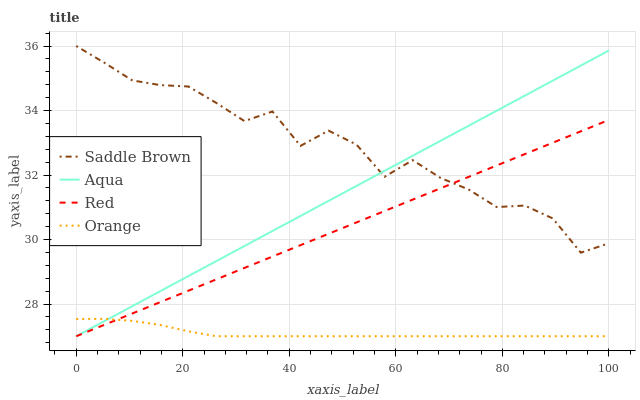Does Orange have the minimum area under the curve?
Answer yes or no. Yes. Does Saddle Brown have the maximum area under the curve?
Answer yes or no. Yes. Does Aqua have the minimum area under the curve?
Answer yes or no. No. Does Aqua have the maximum area under the curve?
Answer yes or no. No. Is Red the smoothest?
Answer yes or no. Yes. Is Saddle Brown the roughest?
Answer yes or no. Yes. Is Aqua the smoothest?
Answer yes or no. No. Is Aqua the roughest?
Answer yes or no. No. Does Orange have the lowest value?
Answer yes or no. Yes. Does Saddle Brown have the lowest value?
Answer yes or no. No. Does Saddle Brown have the highest value?
Answer yes or no. Yes. Does Aqua have the highest value?
Answer yes or no. No. Is Orange less than Saddle Brown?
Answer yes or no. Yes. Is Saddle Brown greater than Orange?
Answer yes or no. Yes. Does Orange intersect Red?
Answer yes or no. Yes. Is Orange less than Red?
Answer yes or no. No. Is Orange greater than Red?
Answer yes or no. No. Does Orange intersect Saddle Brown?
Answer yes or no. No. 